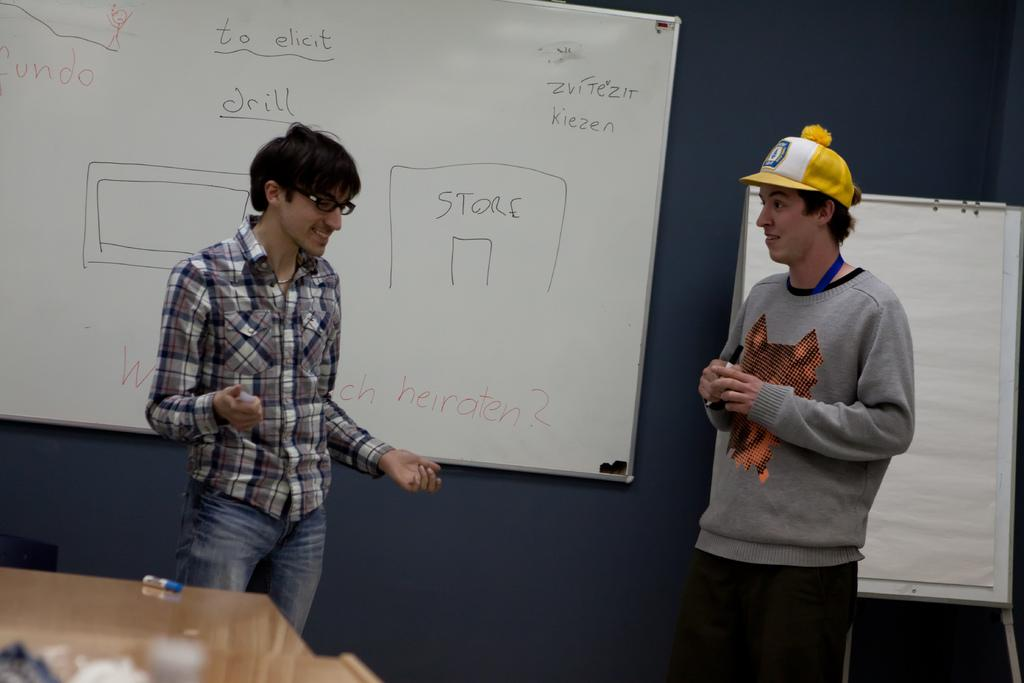<image>
Summarize the visual content of the image. Two men are talking in front of a dry erase board that has store written on it. 